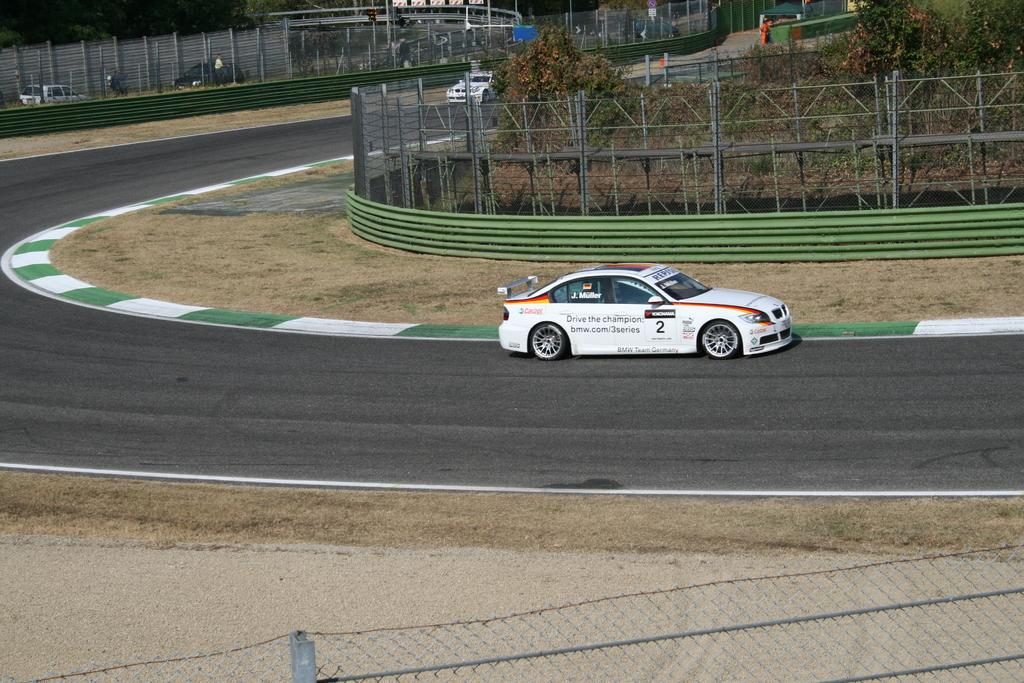What color is the car on the road in the image? The car on the road is white. What is located beside the car on the road? There is fencing beside the car. What can be seen at the top of the image? At the top of the image, there are poles, fencing, a car, a bike, a wooden partition, and people visible. What type of bone is visible in the image? There is no bone present in the image. What sign can be seen on the car in the image? There is no sign visible on the car in the image. 